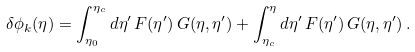Convert formula to latex. <formula><loc_0><loc_0><loc_500><loc_500>\delta \phi _ { k } ( \eta ) = \int _ { \eta _ { 0 } } ^ { \eta _ { c } } d \eta ^ { \prime } \, F ( \eta ^ { \prime } ) \, G ( \eta , \eta ^ { \prime } ) + \int _ { \eta _ { c } } ^ { \eta } d \eta ^ { \prime } \, F ( \eta ^ { \prime } ) \, G ( \eta , \eta ^ { \prime } ) \, .</formula> 